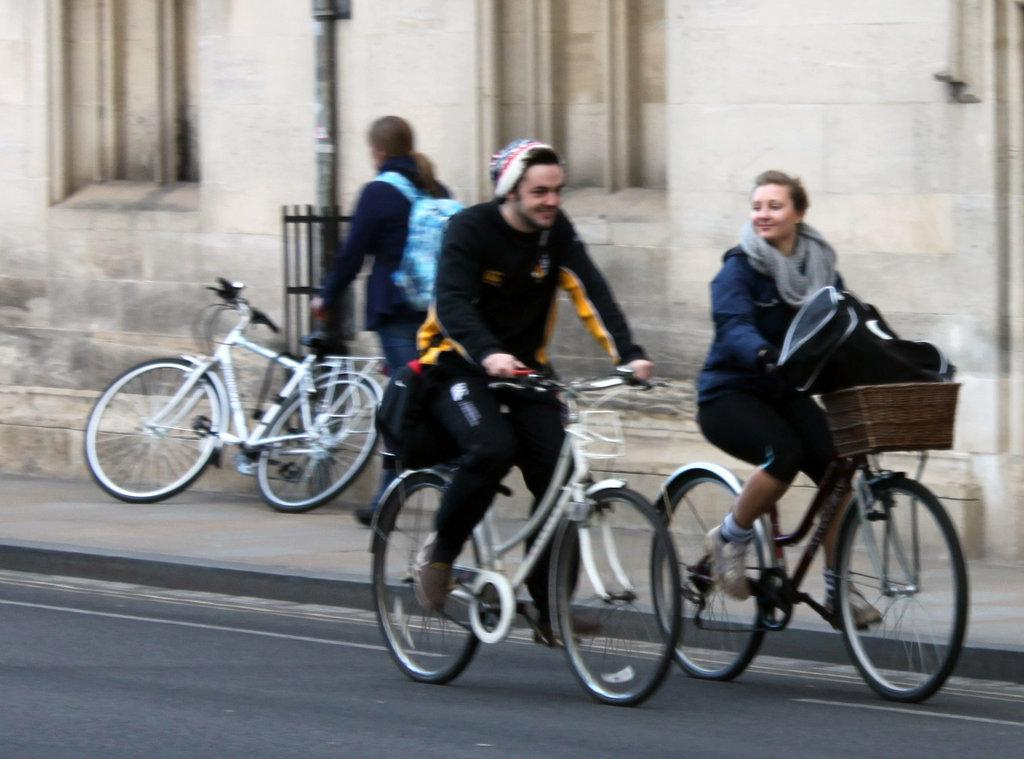How many people are riding the bicycle in the image? There are 2 persons riding the bicycle in the image. Can you describe the scene in the background? There is another person near the bicycle, a building, and a pole in the background of the image. What type of lace is being used to decorate the basketball in the image? There is no basketball present in the image, so there is no lace being used to decorate it. 